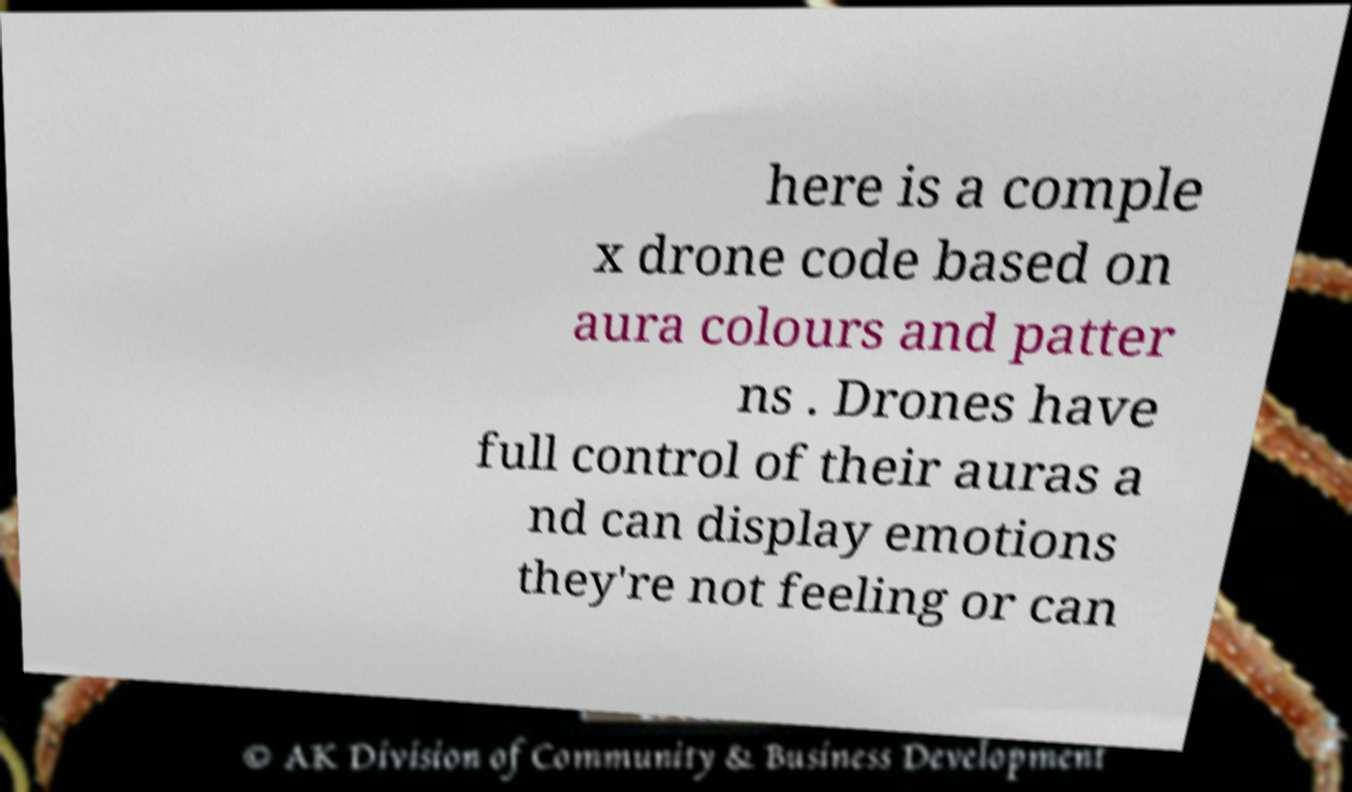Can you read and provide the text displayed in the image?This photo seems to have some interesting text. Can you extract and type it out for me? here is a comple x drone code based on aura colours and patter ns . Drones have full control of their auras a nd can display emotions they're not feeling or can 